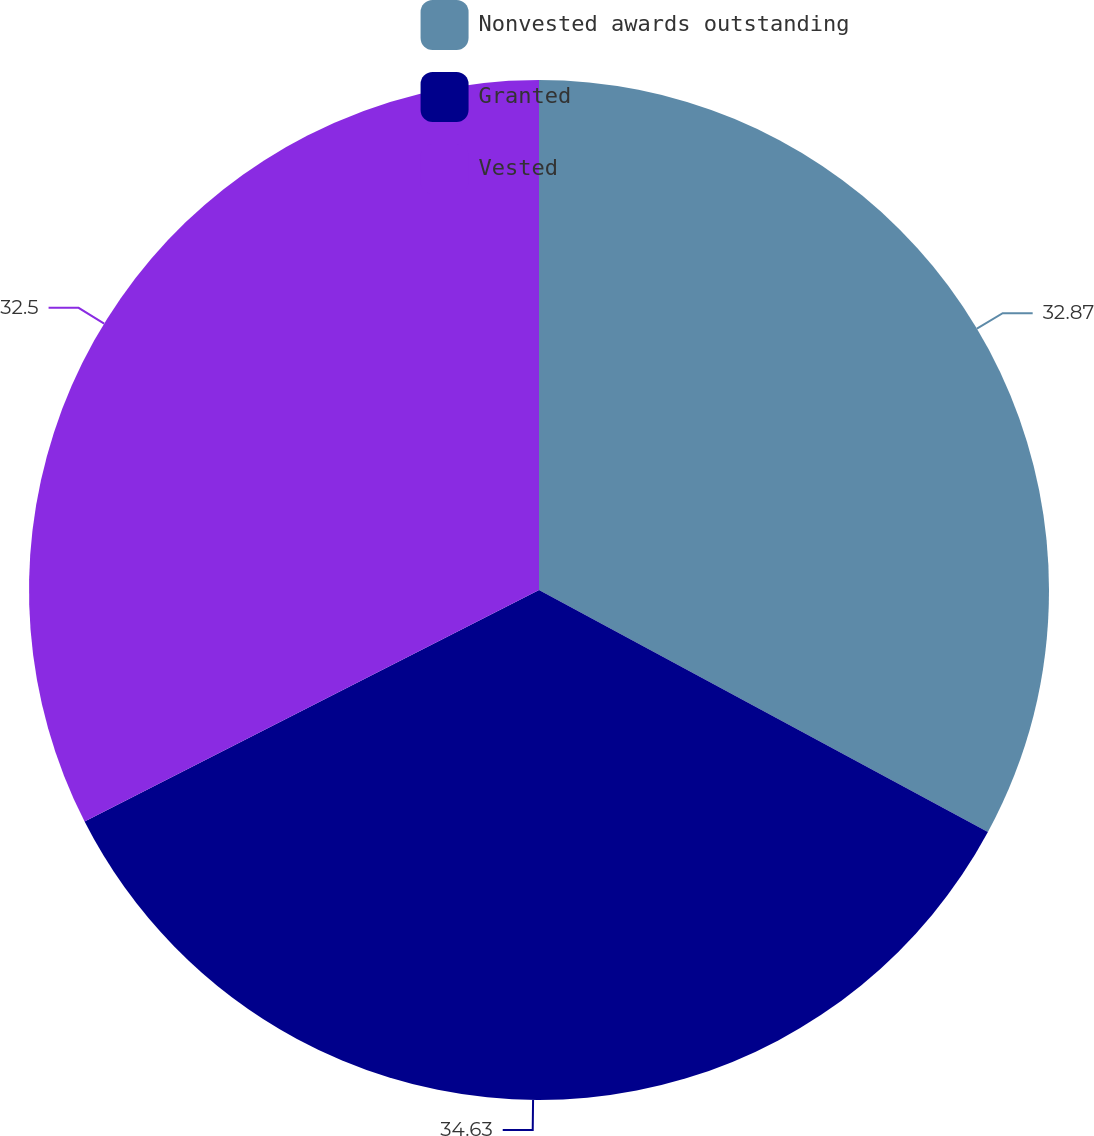Convert chart. <chart><loc_0><loc_0><loc_500><loc_500><pie_chart><fcel>Nonvested awards outstanding<fcel>Granted<fcel>Vested<nl><fcel>32.87%<fcel>34.63%<fcel>32.5%<nl></chart> 